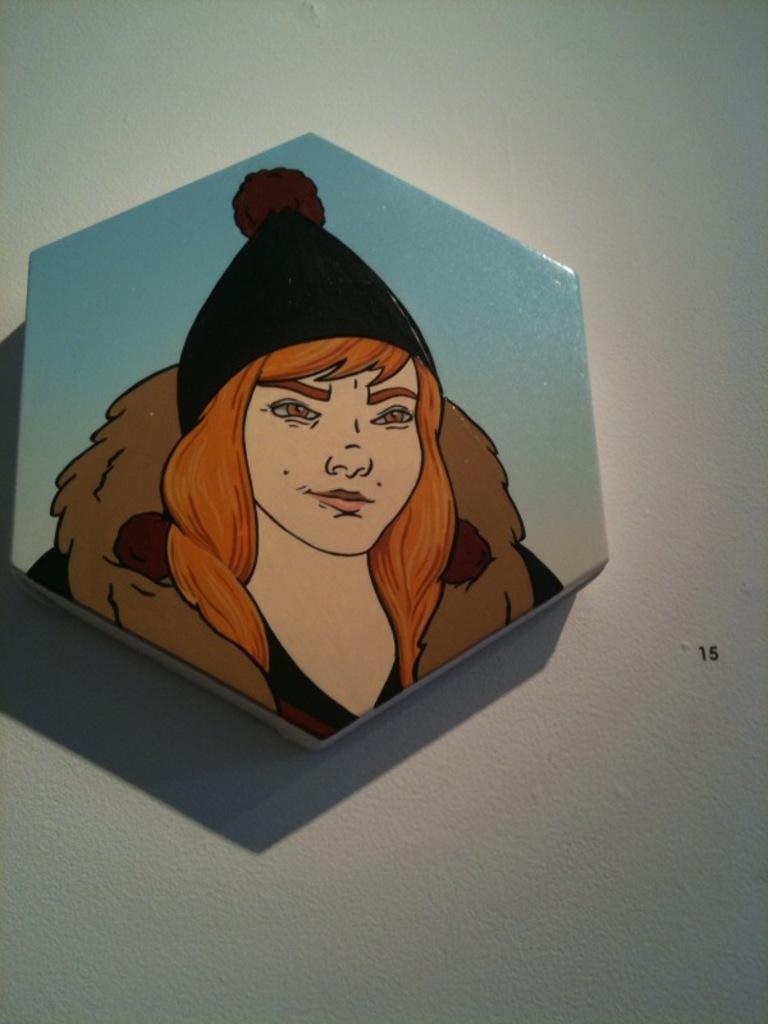Can you describe this image briefly? In this image there is a wall for that wall there is a frame, on that frame there is a painting of a lady. 